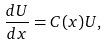Convert formula to latex. <formula><loc_0><loc_0><loc_500><loc_500>\frac { d U } { d x } = C ( x ) U ,</formula> 